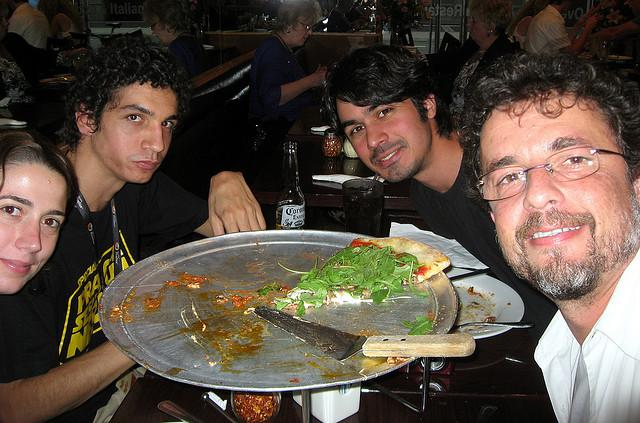What is covering the last slice of pizza available on the tray? spinach 